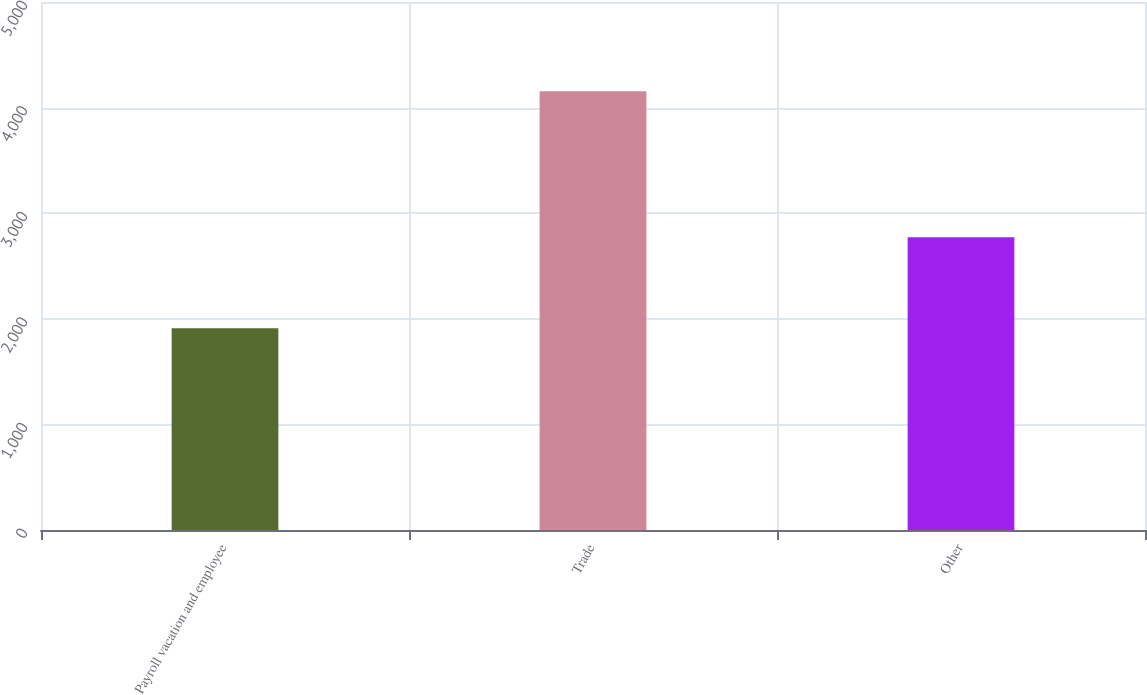Convert chart to OTSL. <chart><loc_0><loc_0><loc_500><loc_500><bar_chart><fcel>Payroll vacation and employee<fcel>Trade<fcel>Other<nl><fcel>1910<fcel>4155<fcel>2772<nl></chart> 